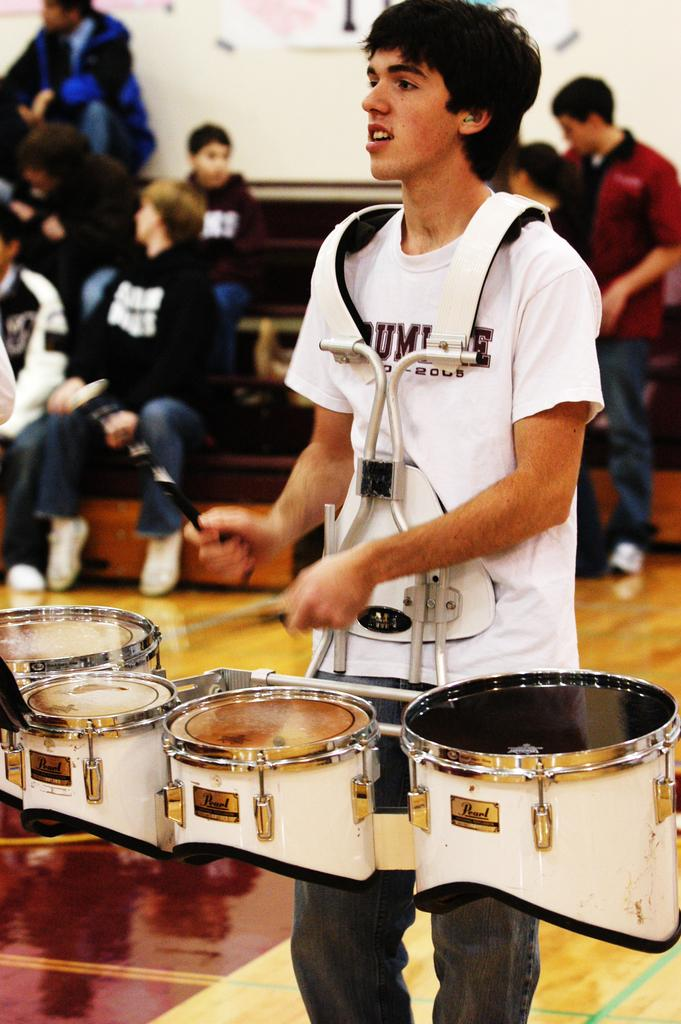What is the man in the image doing? The man is playing the drums. Can you describe the activity of the people in the background of the image? The people in the background are sitting on stairs. What type of quiet stick can be seen in the image? There is no stick, quiet or otherwise, present in the image. 